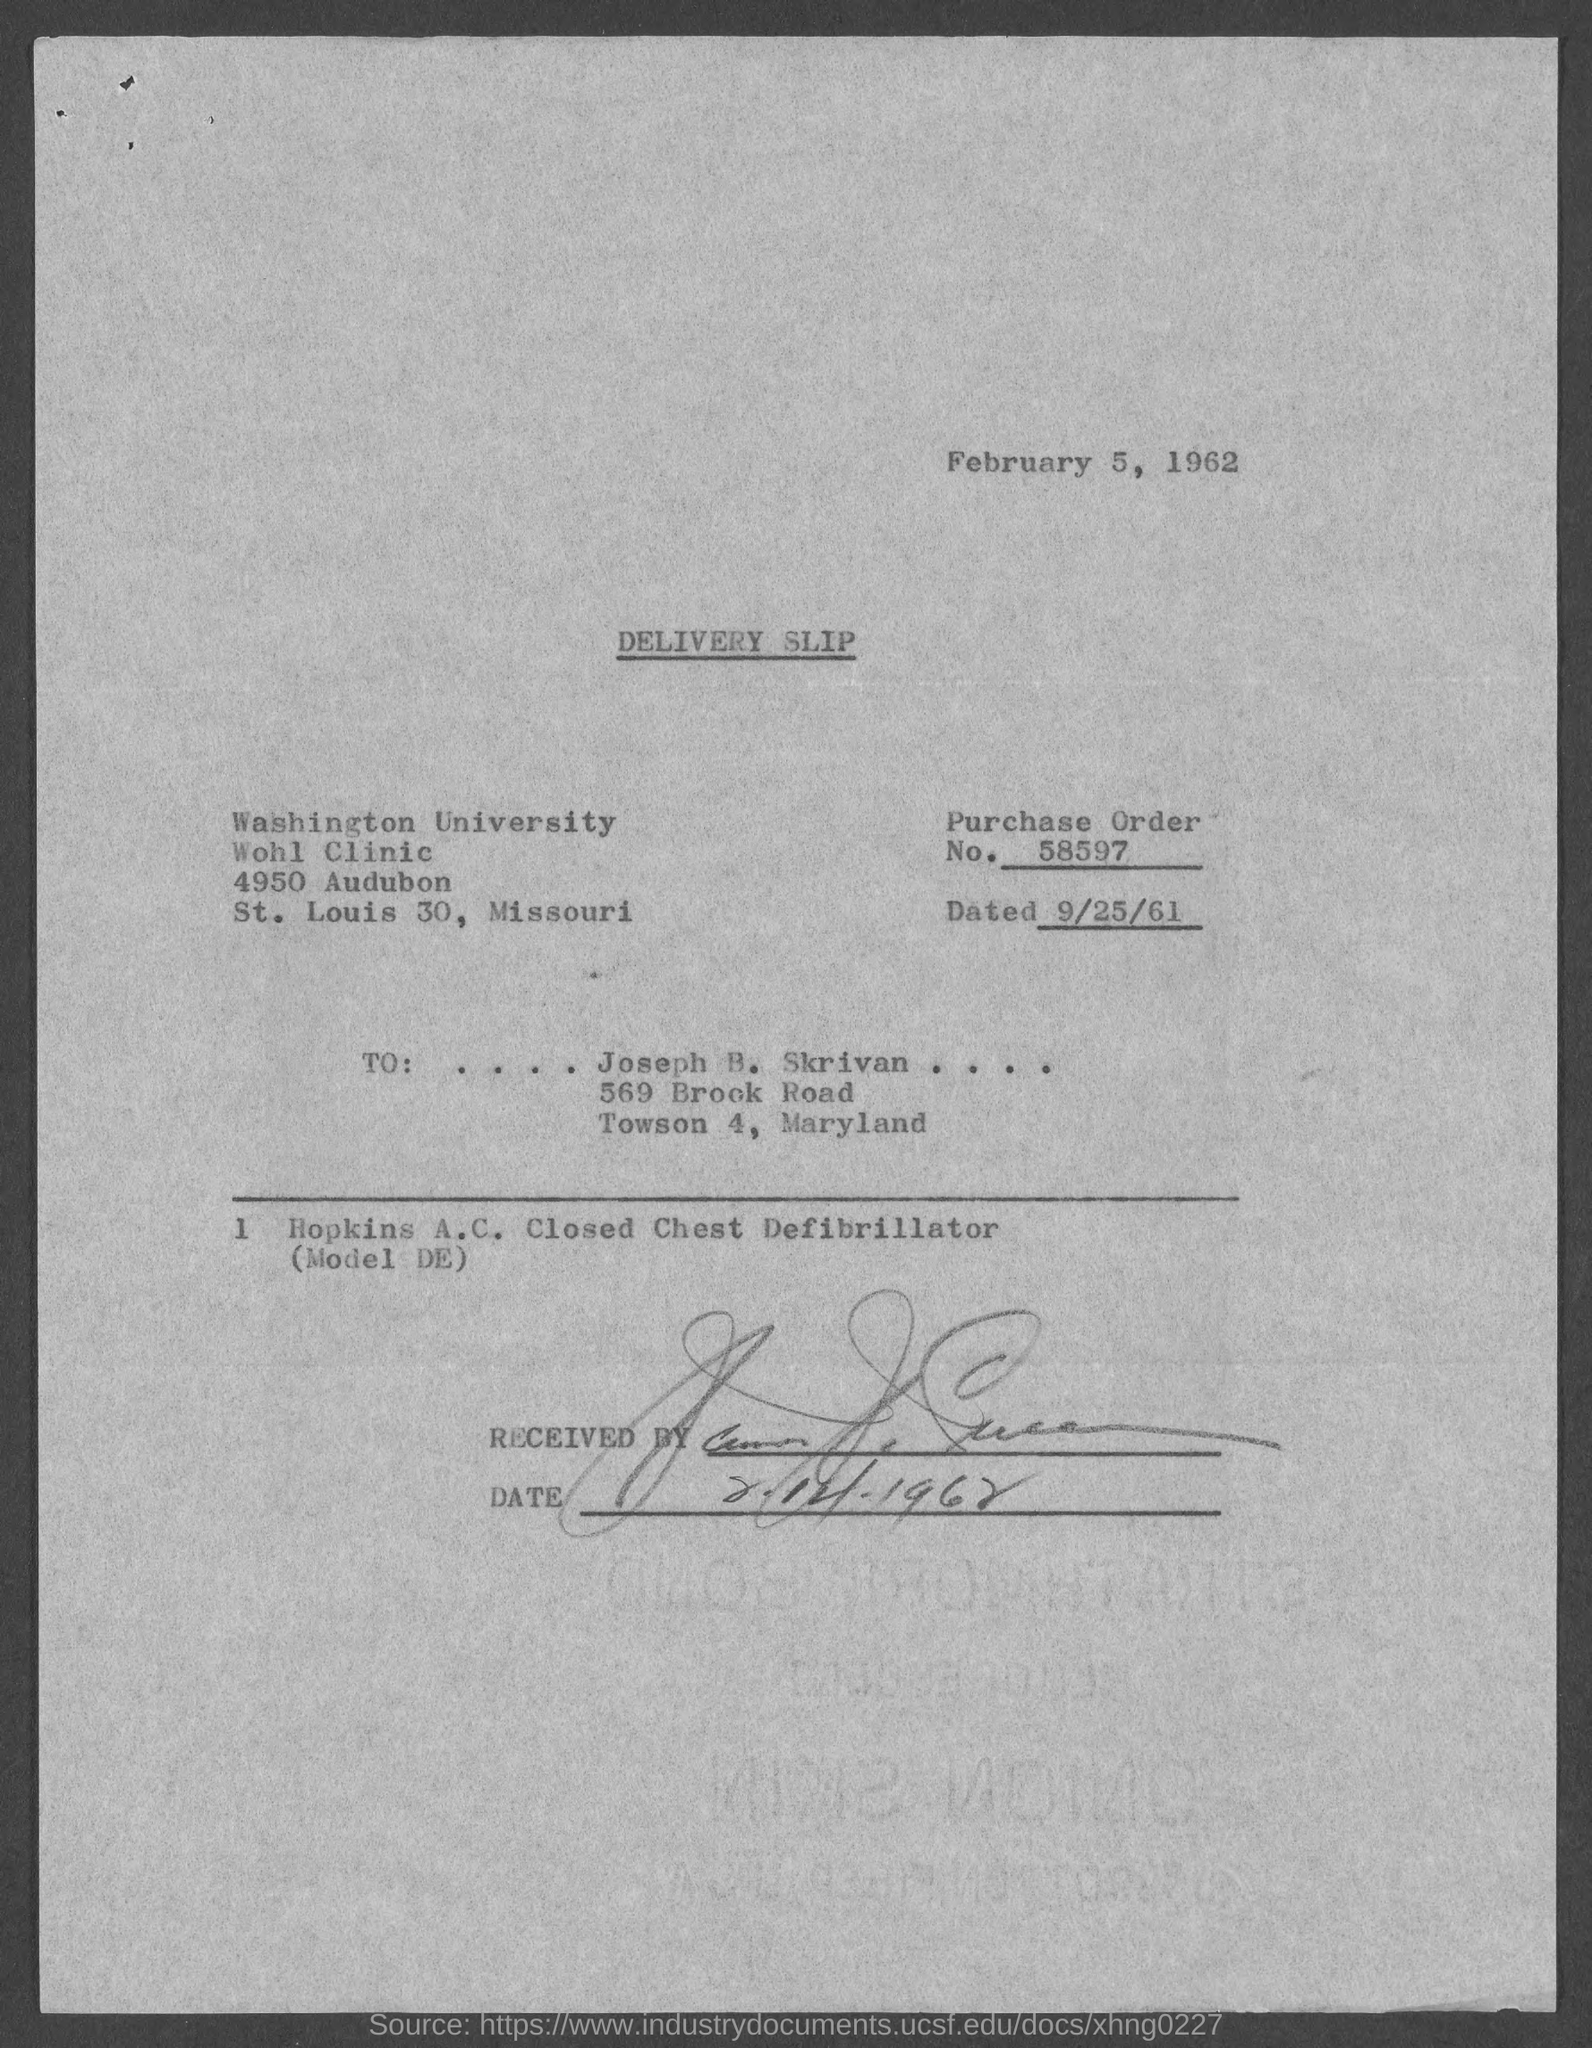List a handful of essential elements in this visual. The heading of the document is "Delivery Slip. The document indicates that the date on top of it is February 5, 1962. 